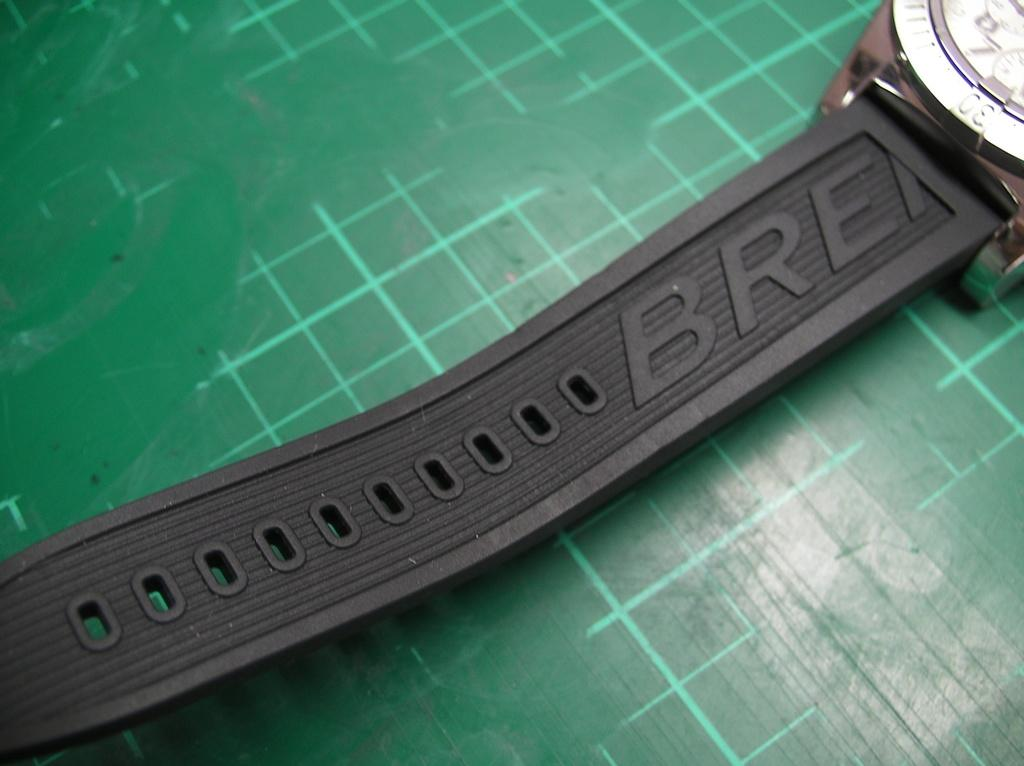<image>
Give a short and clear explanation of the subsequent image. The strap of a watch in black rubber which has the letters BRE on it. 